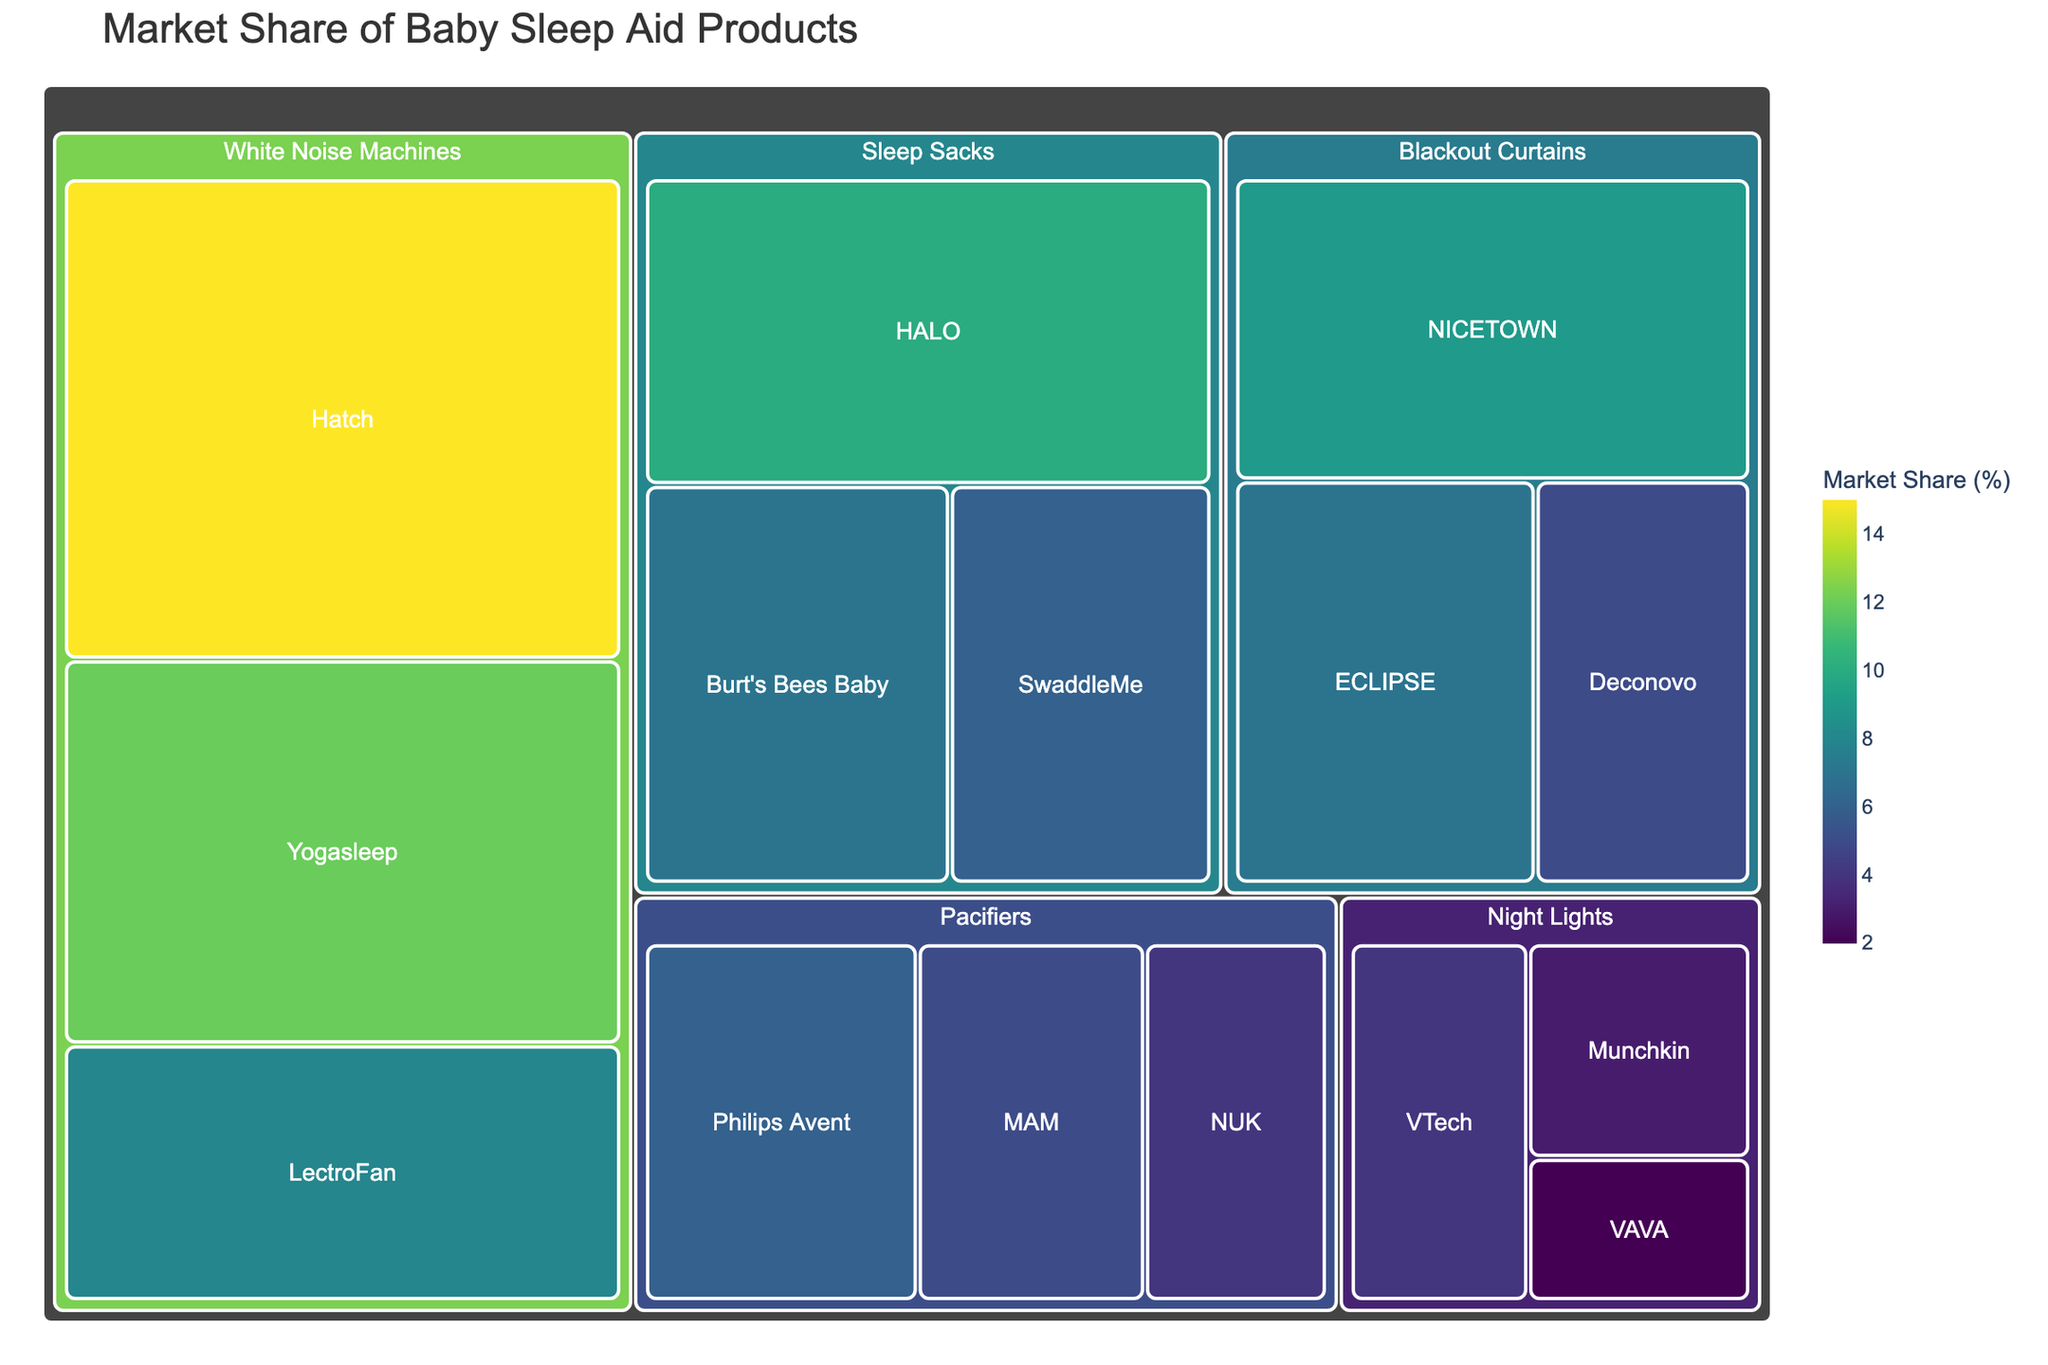What is the title of the treemap? The title is generally placed at the top of the figure, often in a larger font size to make it stand out. It summarizes the content or purpose of the chart.
Answer: Market Share of Baby Sleep Aid Products Which brand has the highest market share in the White Noise Machines category? To find this, visually locate the "White Noise Machines" section in the treemap and identify which brand occupies the largest area.
Answer: Hatch What is the combined market share of the brands in the Sleep Sacks category? Add the market shares of HALO, Burt's Bees Baby, and SwaddleMe from the Sleep Sacks section. This involves simple addition.
Answer: 23 Which category has the smallest overall market share? Look at the sections representing categories and visually compare their sizes. The smallest area corresponds to the smallest market share.
Answer: Night Lights How does the market share of NICETOWN compare to ECLIPSE in the Blackout Curtains category? Within the Blackout Curtains section, compare the sizes of the areas for NICETOWN and ECLIPSE.
Answer: NICETOWN has a higher market share than ECLIPSE What is the total market share captured by Night Lights and Pacifiers combined? Find the respective sections and sum up the market shares of all brands under Night Lights and Pacifiers.
Answer: 24 Which category has the most brands represented in the treemap? Count the number of distinct brands within each category section. The category with the highest count wins.
Answer: White Noise Machines Among all the brands, which one has the lowest market share? Visually scan for the smallest individual area in the treemap, representing the lowest market share.
Answer: VAVA Is there any category where no single brand holds more than 10% market share? Check each category to see if all brand market shares are below 10%.
Answer: Yes, Night Lights What is the difference in market share between the top White Noise Machines brand and the top Sleep Sacks brand? Identify the market shares of Hatch from White Noise Machines and HALO from Sleep Sacks, then subtract them.
Answer: 5 